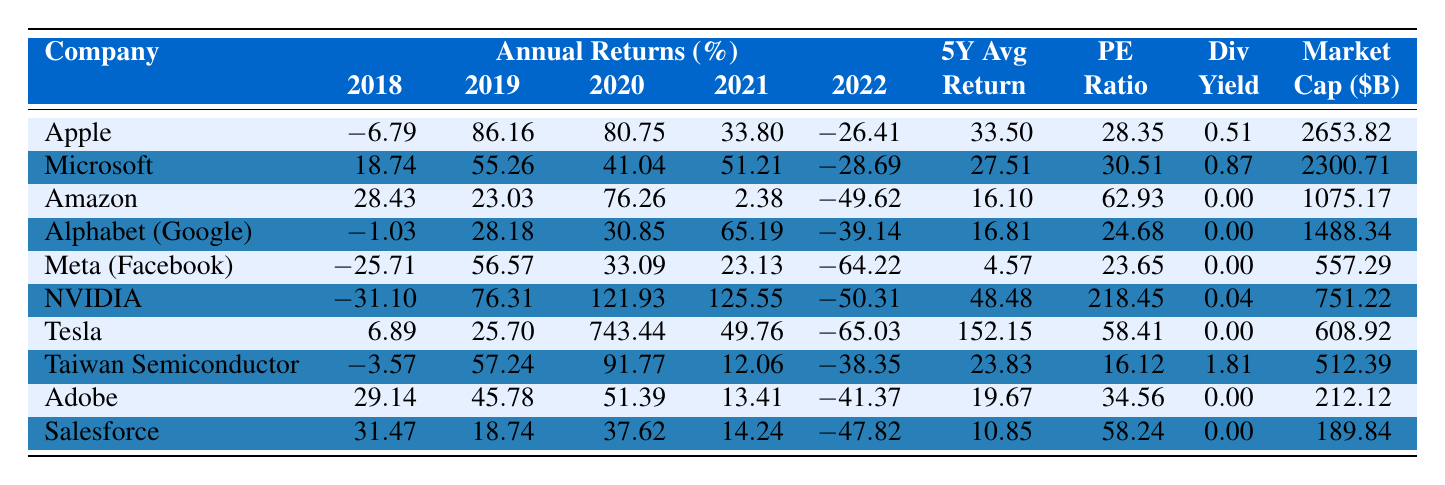What was the highest annual return in 2020? Looking at the 2020 returns, Tesla has the highest return at 743.44%.
Answer: 743.44% Which company had the lowest 5-year average return? By examining the 5Y Avg Return column, Meta (Facebook) has the lowest average at 4.57%.
Answer: 4.57% Did Amazon have a dividend yield in 2023? According to the Dividend Yield column, Amazon shows a yield of 0.00%, indicating no dividends were issued.
Answer: No What is the difference between Apple’s and Microsoft’s 5-year average returns? Apple’s 5Y Avg is 33.50% while Microsoft’s is 27.51%. The difference is 33.50 - 27.51 = 5.99%.
Answer: 5.99% Which company had the largest market capitalization? Looking at the Market Cap column, Apple has the highest market capitalization at $2653.82 billion.
Answer: $2653.82 billion What percentage return did Netflix achieve in 2018 and how does it compare to Apple? Netflix isn't listed in the table; thus, we can't determine its 2018 return. Apple had a return of -6.79%.
Answer: Not applicable What was the average return of all the companies in 2021? To find the average of the 2021 returns, we add up the returns for that year (33.80 + 51.21 + 2.38 + 65.19 + 23.13 + 125.55 + 49.76 + 12.06 + 13.41 + 14.24) = 413.73 and divide by 10, resulting in an average of 41.37%.
Answer: 41.37% Which company experienced the most volatile returns based on the percentage changes in annual returns? By assessing the annual return percentages, Tesla shows the highest deviation from the mean, especially with a peak of 743.44% in 2020 and a drastic drop in 2022.
Answer: Tesla How many companies had a negative return in 2022? In the 2022 Return column, Apple, Microsoft, Amazon, Alphabet, Meta, NVIDIA, Tesla, Adobe, and Salesforce have negative returns. Counting these gives us 8 companies.
Answer: 8 companies What is the overall trend of NVIDIA's returns over the last 5 years? Analyzing the yearly returns, NVIDIA shows increasing returns over the years, peaking in 2021 at 125.55%, despite a decline in 2022.
Answer: Increasing with a peak in 2021 Which company had the highest PE ratio and how does it compare to the lowest PE ratio? NVIDIA had the highest PE ratio at 218.45, while Taiwan Semiconductor had the lowest at 16.12, leading to a comparison difference of 218.45 - 16.12 = 202.33.
Answer: 202.33 